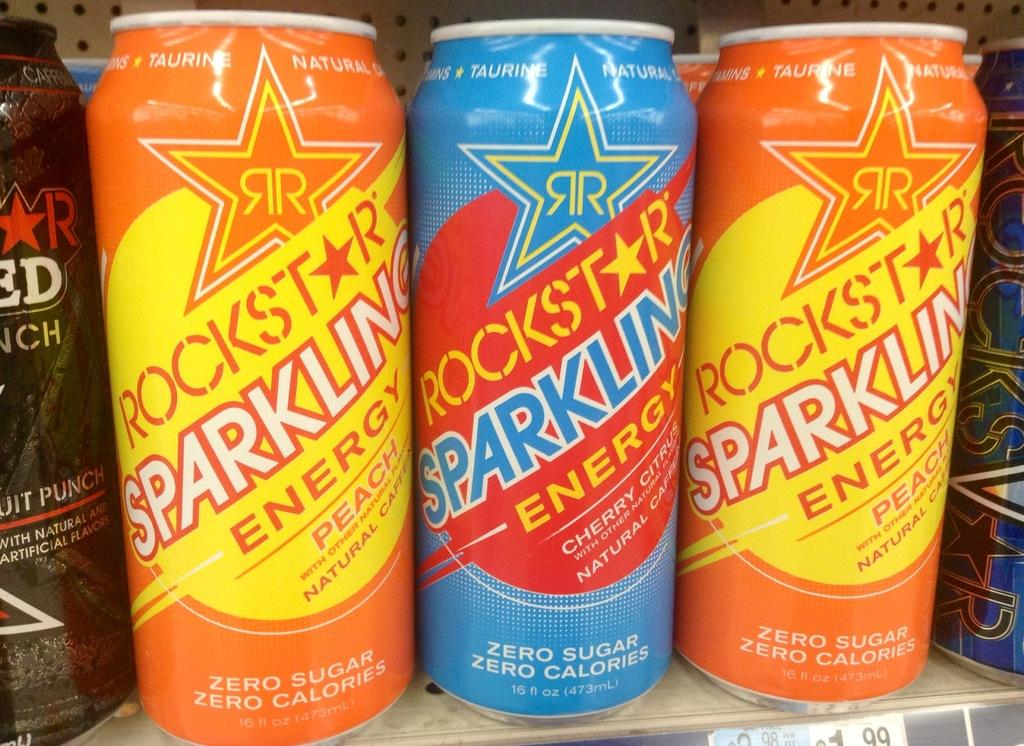<image>
Create a compact narrative representing the image presented. several cans of different flavored Rockstar are on a shelf 